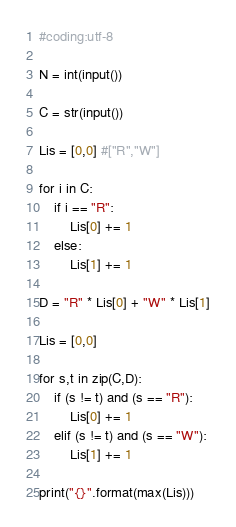Convert code to text. <code><loc_0><loc_0><loc_500><loc_500><_Python_>#coding:utf-8

N = int(input())

C = str(input())

Lis = [0,0] #["R","W"]

for i in C:
    if i == "R":
        Lis[0] += 1
    else:
        Lis[1] += 1

D = "R" * Lis[0] + "W" * Lis[1]

Lis = [0,0]

for s,t in zip(C,D):
    if (s != t) and (s == "R"):
        Lis[0] += 1
    elif (s != t) and (s == "W"):
        Lis[1] += 1

print("{}".format(max(Lis)))</code> 